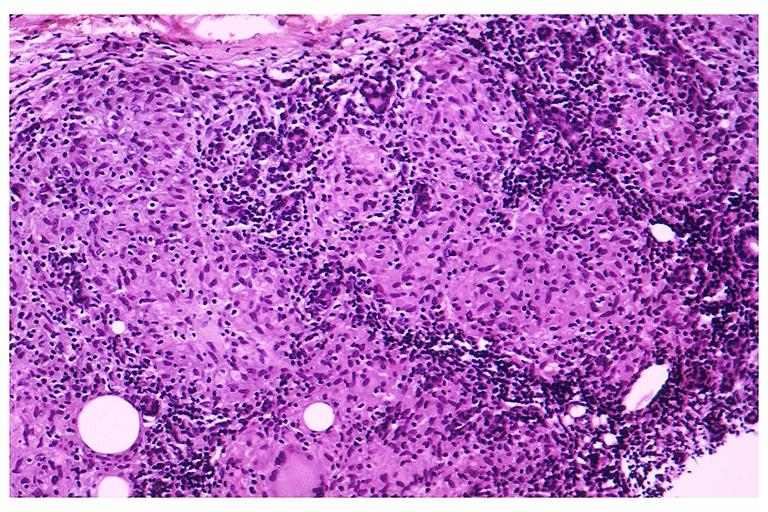what is present?
Answer the question using a single word or phrase. Oral 